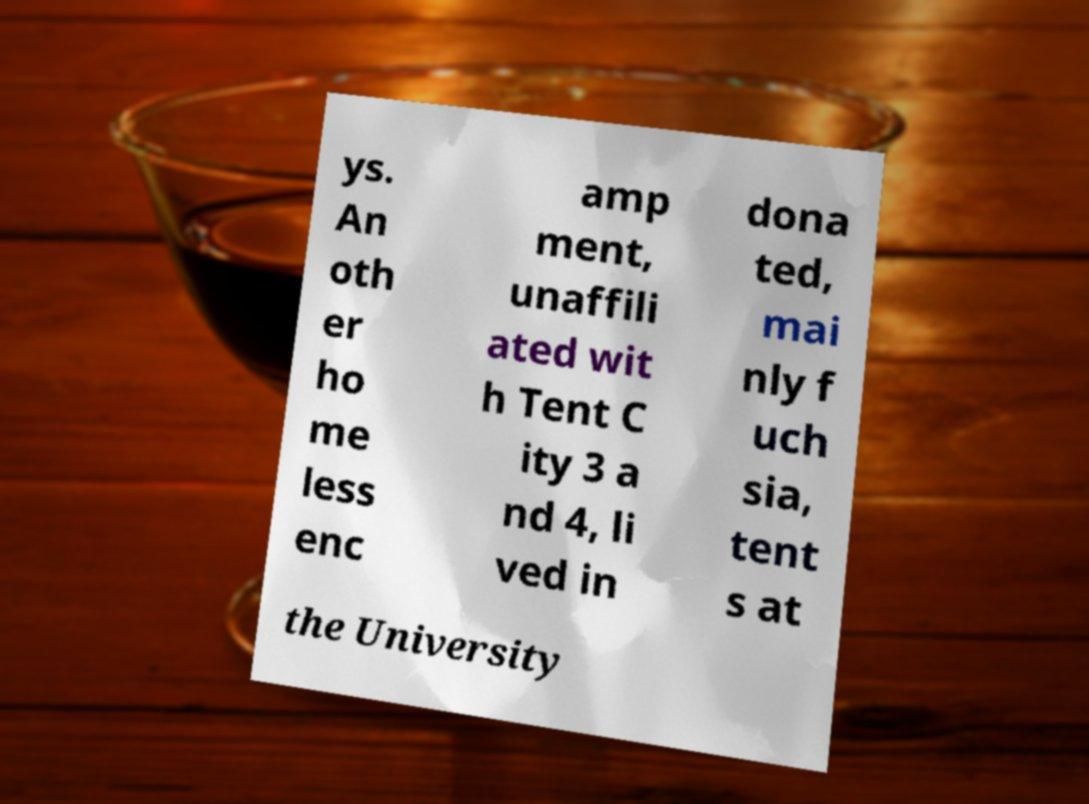I need the written content from this picture converted into text. Can you do that? ys. An oth er ho me less enc amp ment, unaffili ated wit h Tent C ity 3 a nd 4, li ved in dona ted, mai nly f uch sia, tent s at the University 